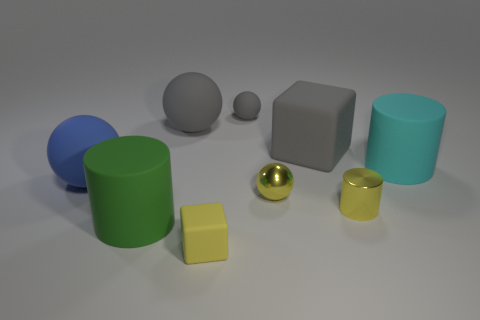Does the tiny rubber cube have the same color as the small shiny ball?
Your answer should be very brief. Yes. Does the block that is behind the cyan rubber cylinder have the same color as the tiny matte sphere?
Your response must be concise. Yes. Is the number of cubes in front of the tiny metallic cylinder less than the number of yellow things?
Offer a terse response. Yes. What is the size of the rubber cube that is the same color as the shiny cylinder?
Offer a terse response. Small. Is the material of the small yellow cube the same as the yellow cylinder?
Provide a succinct answer. No. How many things are yellow objects in front of the yellow cylinder or large rubber things left of the large gray sphere?
Your response must be concise. 3. Is there a cyan rubber cylinder of the same size as the yellow block?
Ensure brevity in your answer.  No. The other big rubber thing that is the same shape as the big cyan matte object is what color?
Offer a very short reply. Green. Are there any large matte balls that are in front of the big ball that is behind the cyan object?
Make the answer very short. Yes. Is the shape of the gray rubber object on the right side of the small gray rubber sphere the same as  the small yellow rubber object?
Make the answer very short. Yes. 